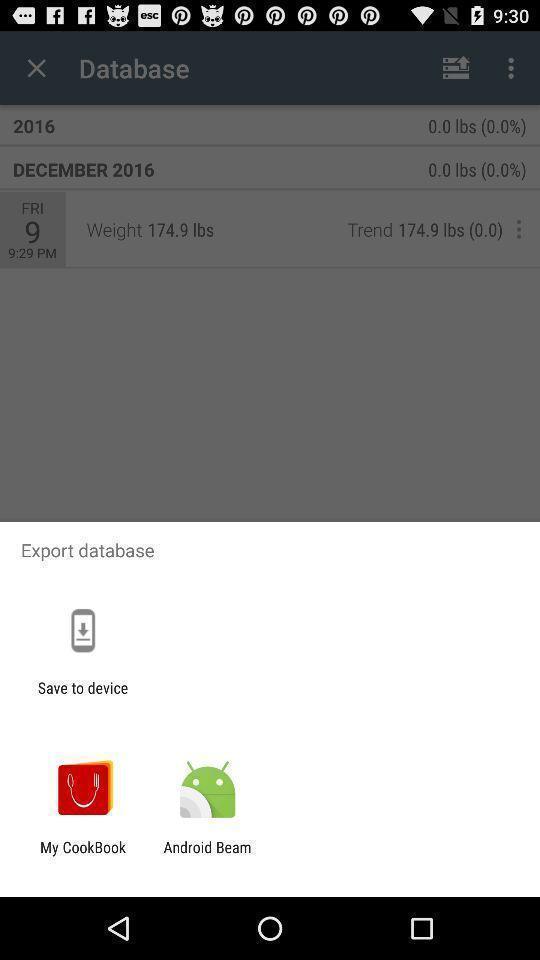Give me a narrative description of this picture. Pop up showing various apps. 